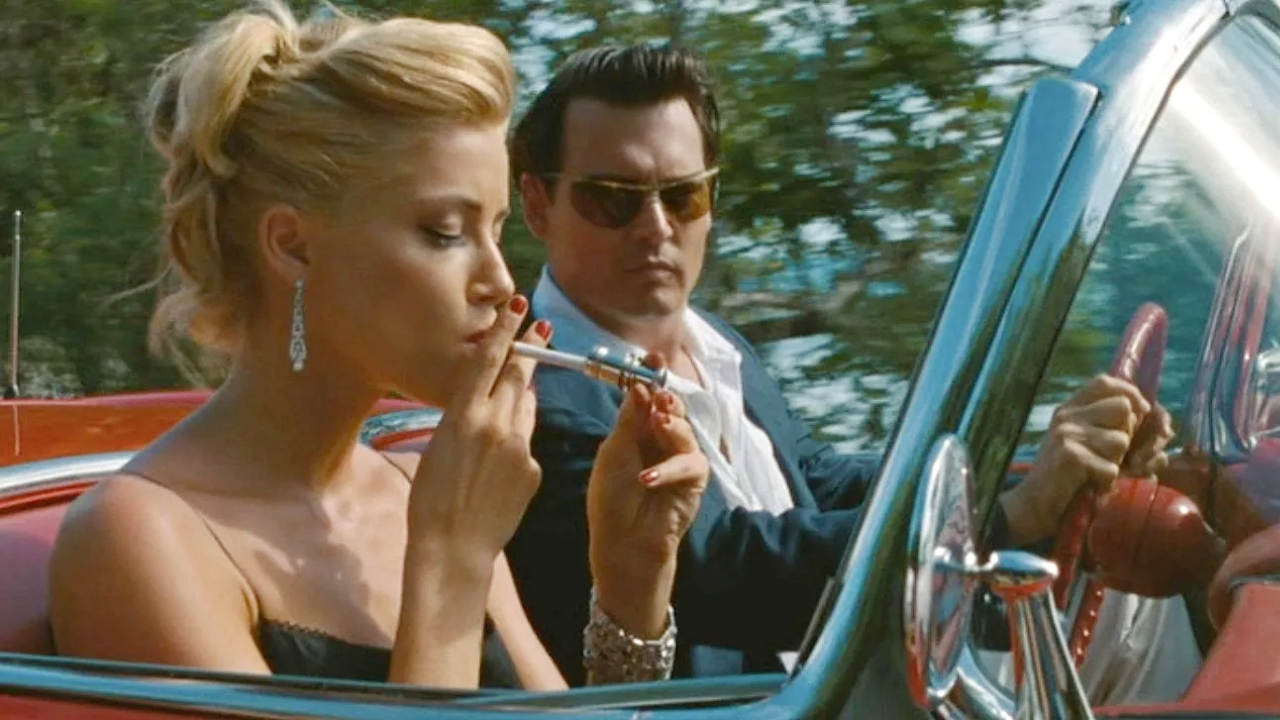Can you elaborate on the elements of the picture provided? The image features a scene from 'The Rum Diary,' where Amber Heard, portraying Chenault, is seated in a striking red convertible. Dressed in an elegant gold dress complemented by matching earrings, she exudes a 60s glamour, smoking a cigarette with a poised demeanor. Johnny Depp, playing Paul Kemp, appears next to her in the passenger seat, dressed in a classic black suit paired with sunglasses, enhancing his mysterious allure. The car is parked in a lush green environment, suggesting a secluded or private setting. This setting, combined with the vintage car and the actors' attire, evokes a nostalgic and atmospheric mood fitting the film’s historical context. 